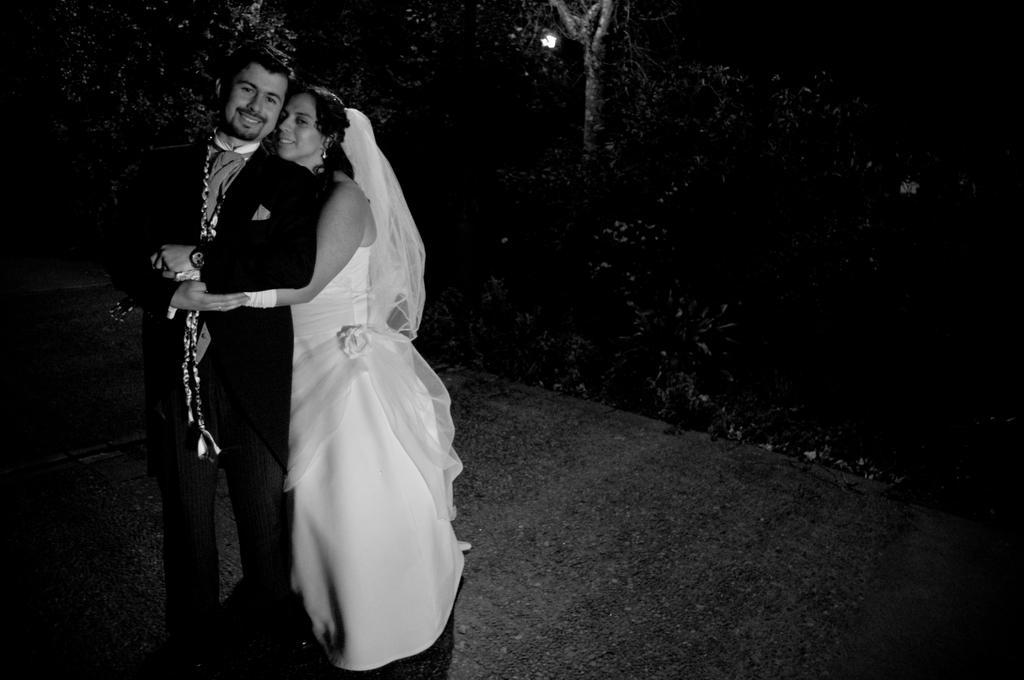In one or two sentences, can you explain what this image depicts? In this black and white picture a person is wearing a suit. He is standing on the floor. Behind him there is a woman wearing a dress is holding the person. Background there are few trees. 